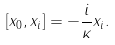<formula> <loc_0><loc_0><loc_500><loc_500>[ x _ { 0 } , x _ { i } ] = - \frac { i } \kappa x _ { i } .</formula> 